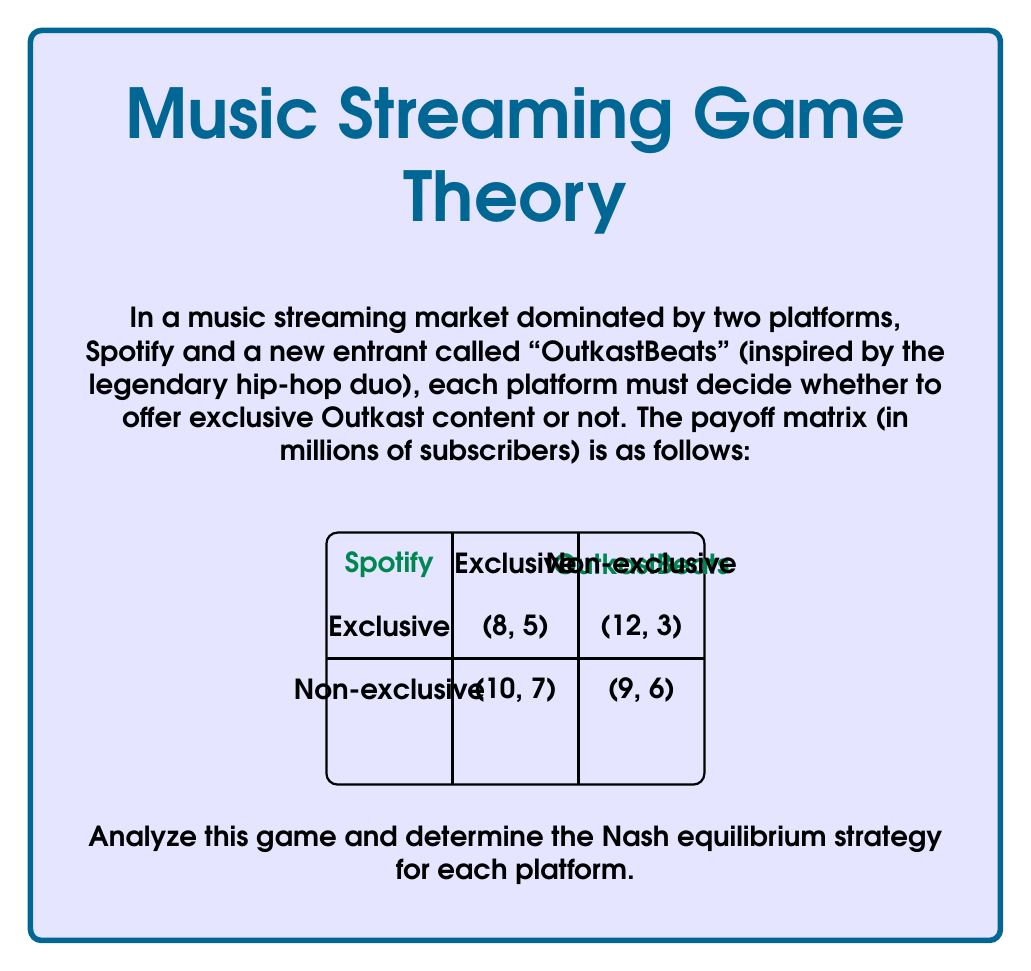Show me your answer to this math problem. To find the Nash equilibrium, we need to analyze each platform's best response to the other's strategy:

1. Spotify's perspective:
   - If OutkastBeats chooses Exclusive:
     Spotify Exclusive: 8 million subscribers
     Spotify Non-exclusive: 10 million subscribers
     Best response: Non-exclusive
   - If OutkastBeats chooses Non-exclusive:
     Spotify Exclusive: 12 million subscribers
     Spotify Non-exclusive: 9 million subscribers
     Best response: Exclusive

2. OutkastBeats' perspective:
   - If Spotify chooses Exclusive:
     OutkastBeats Exclusive: 5 million subscribers
     OutkastBeats Non-exclusive: 3 million subscribers
     Best response: Exclusive
   - If Spotify chooses Non-exclusive:
     OutkastBeats Exclusive: 7 million subscribers
     OutkastBeats Non-exclusive: 6 million subscribers
     Best response: Exclusive

3. Identifying Nash equilibrium:
   A Nash equilibrium occurs when neither player can unilaterally improve their payoff by changing their strategy.

   From the analysis above, we can see that:
   - OutkastBeats' dominant strategy is Exclusive (always the best response)
   - Spotify's best response to OutkastBeats' Exclusive strategy is Non-exclusive

Therefore, the Nash equilibrium is (Spotify: Non-exclusive, OutkastBeats: Exclusive), resulting in payoffs of (10, 7) million subscribers respectively.

This equilibrium reflects a realistic scenario where a new entrant (OutkastBeats) differentiates itself with exclusive content from a popular artist (Outkast), while the established player (Spotify) maintains a broader, non-exclusive catalog.
Answer: (Spotify: Non-exclusive, OutkastBeats: Exclusive) 